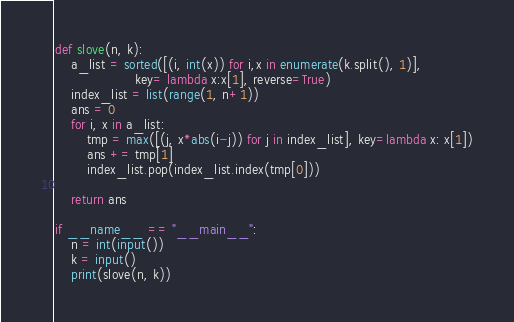<code> <loc_0><loc_0><loc_500><loc_500><_Python_>def slove(n, k):
    a_list = sorted([(i, int(x)) for i,x in enumerate(k.split(), 1)],
                    key= lambda x:x[1], reverse=True)
    index_list = list(range(1, n+1))
    ans = 0
    for i, x in a_list:
        tmp = max([(j, x*abs(i-j)) for j in index_list], key=lambda x: x[1])
        ans += tmp[1]
        index_list.pop(index_list.index(tmp[0]))

    return ans

if __name__ == "__main__":
    n = int(input())
    k = input()
    print(slove(n, k))
</code> 